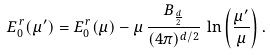<formula> <loc_0><loc_0><loc_500><loc_500>E _ { 0 } ^ { \, r } ( \mu ^ { \prime } ) = E _ { 0 } ^ { \, r } ( \mu ) - \mu \, \frac { B _ { \frac { d } { 2 } } } { ( 4 \pi ) ^ { d / 2 } } \, \ln \left ( \frac { \mu ^ { \prime } } { \mu } \right ) .</formula> 